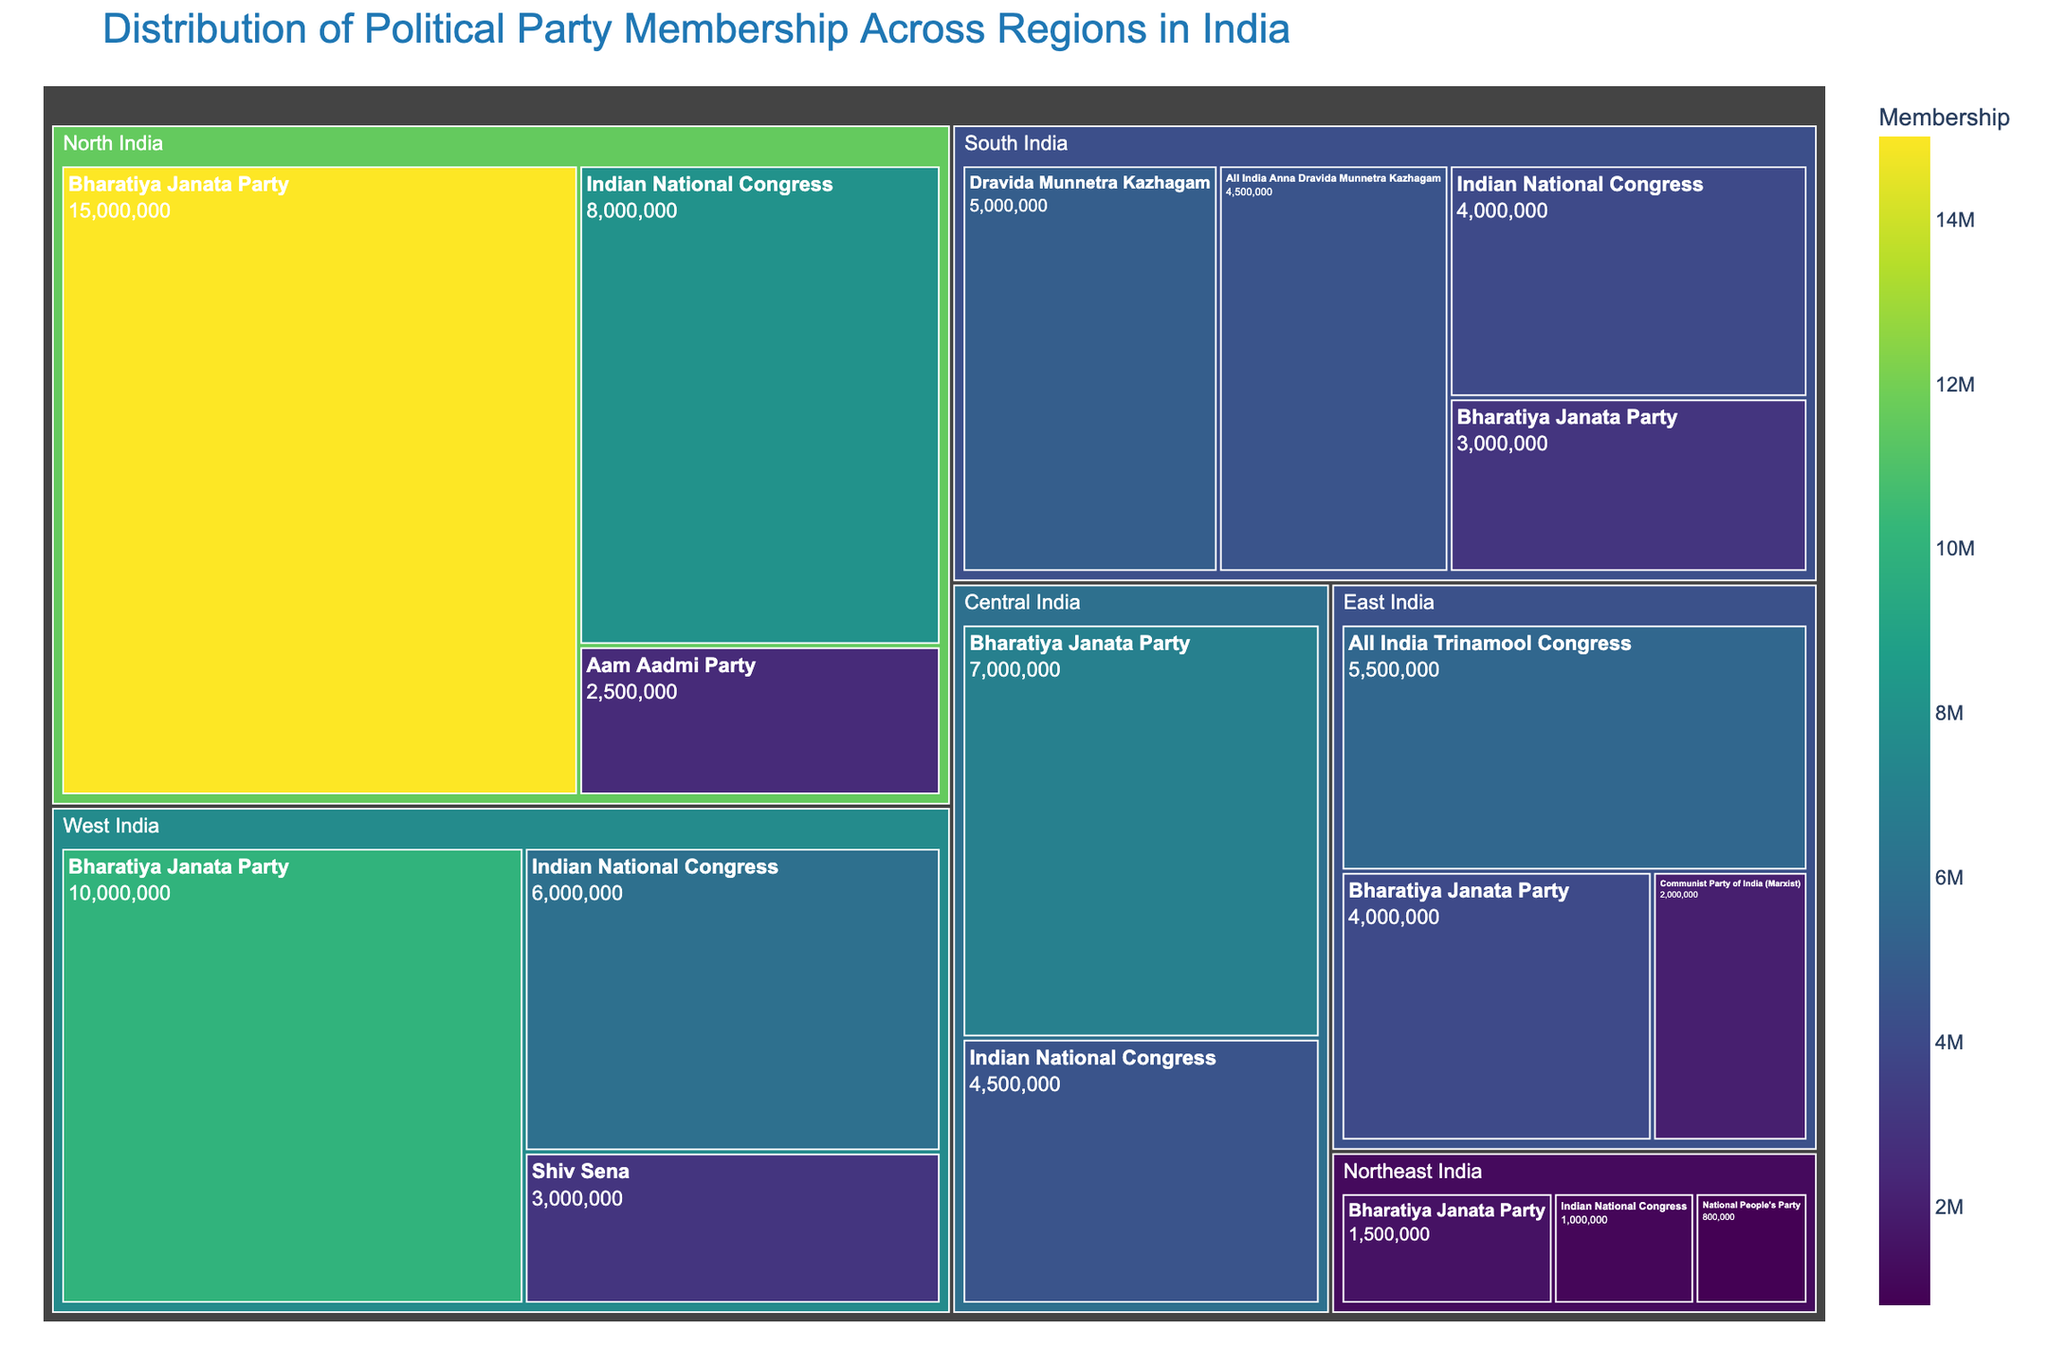What's the title of the figure? The title of the figure is usually mentioned at the top of the treemap. In this case, it says "Distribution of Political Party Membership Across Regions in India".
Answer: Distribution of Political Party Membership Across Regions in India Which political party has the highest membership in North India? To find this out, we look at the largest block within the 'North India' section of the treemap. The Bharatiya Janata Party has the highest membership as its block is the largest.
Answer: Bharatiya Janata Party How many regions are represented in the treemap? Each unique section or group at the first level of the treemap corresponds to a region. By examining the figure, we see that there are six regions: North India, South India, East India, West India, Central India, and Northeast India.
Answer: Six What is the total membership of the Bharatiya Janata Party across all regions? We need to sum the membership numbers of the Bharatiya Janata Party in all regions as shown in the treemap: 15,000,000 (North) + 3,000,000 (South) + 4,000,000 (East) + 10,000,000 (West) + 7,000,000 (Central) + 1,500,000 (Northeast) = 40,500,000.
Answer: 40,500,000 Which region has the lowest total political party membership and what is it? By observing the size of each region's section in the treemap, Northeast India appears to have the smallest combined membership compared to others. The memberships for Northeast India are: 800,000 (National People's Party) + 1,500,000 (Bharatiya Janata Party) + 1,000,000 (Indian National Congress) = 3,300,000.
Answer: Northeast India, 3,300,000 Compare the membership of the Indian National Congress in East India and West India. Which region has more, and by how much? The Indian National Congress has 6,000,000 in West India and 0 in East India. Therefore, West India has more by 6,000,000 - 0 = 6,000,000.
Answer: West India, 6,000,000 What fraction of the total political party membership in South India belongs to regional parties (DMK and AIADMK)? First, calculate the total membership in South India: 5,000,000 (DMK) + 4,500,000 (AIADMK) + 3,000,000 (BJP) + 4,000,000 (INC) = 16,500,000. The combined membership of DMK and AIADMK is 5,000,000 + 4,500,000 = 9,500,000. Thus, the fraction is 9,500,000 / 16,500,000.
Answer: 9,500,000 / 16,500,000 = 19/33 What is the ratio of Bharatiya Janata Party membership in East India to its membership in Central India? The membership of Bharatiya Janata Party in East India is 4,000,000 and in Central India is 7,000,000. Thus, the ratio is 4,000,000:7,000,000 which simplifies to 4:7.
Answer: 4:7 Which region's Indian National Congress membership is closest to 5,000,000? By inspecting the treemap, Indian National Congress has memberships: North India (8,000,000), South India (4,000,000), West India (6,000,000), Central India (4,500,000), and Northeast India (1,000,000). The closest to 5,000,000 is Central India with 4,500,000.
Answer: Central India, 4,500,000 